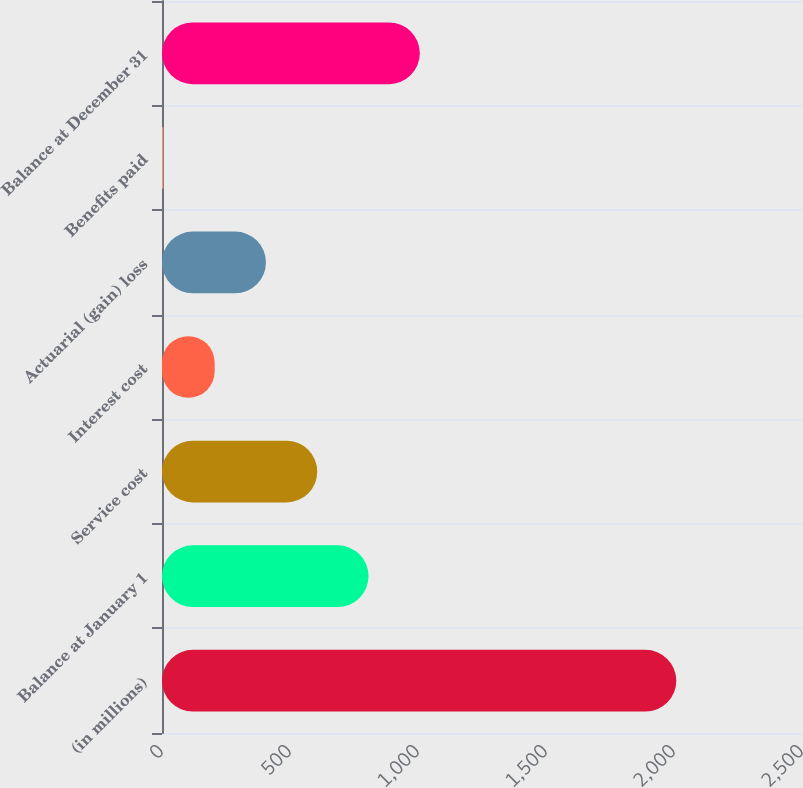<chart> <loc_0><loc_0><loc_500><loc_500><bar_chart><fcel>(in millions)<fcel>Balance at January 1<fcel>Service cost<fcel>Interest cost<fcel>Actuarial (gain) loss<fcel>Benefits paid<fcel>Balance at December 31<nl><fcel>2009<fcel>806.78<fcel>606.41<fcel>205.67<fcel>406.04<fcel>5.3<fcel>1007.15<nl></chart> 